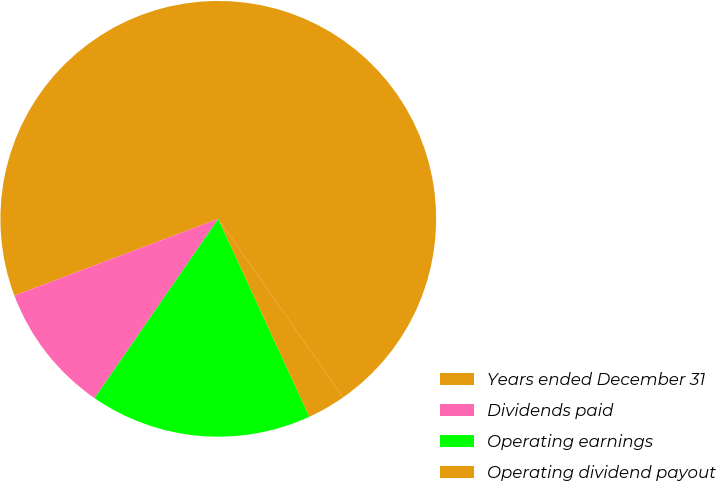Convert chart. <chart><loc_0><loc_0><loc_500><loc_500><pie_chart><fcel>Years ended December 31<fcel>Dividends paid<fcel>Operating earnings<fcel>Operating dividend payout<nl><fcel>71.02%<fcel>9.66%<fcel>16.48%<fcel>2.84%<nl></chart> 